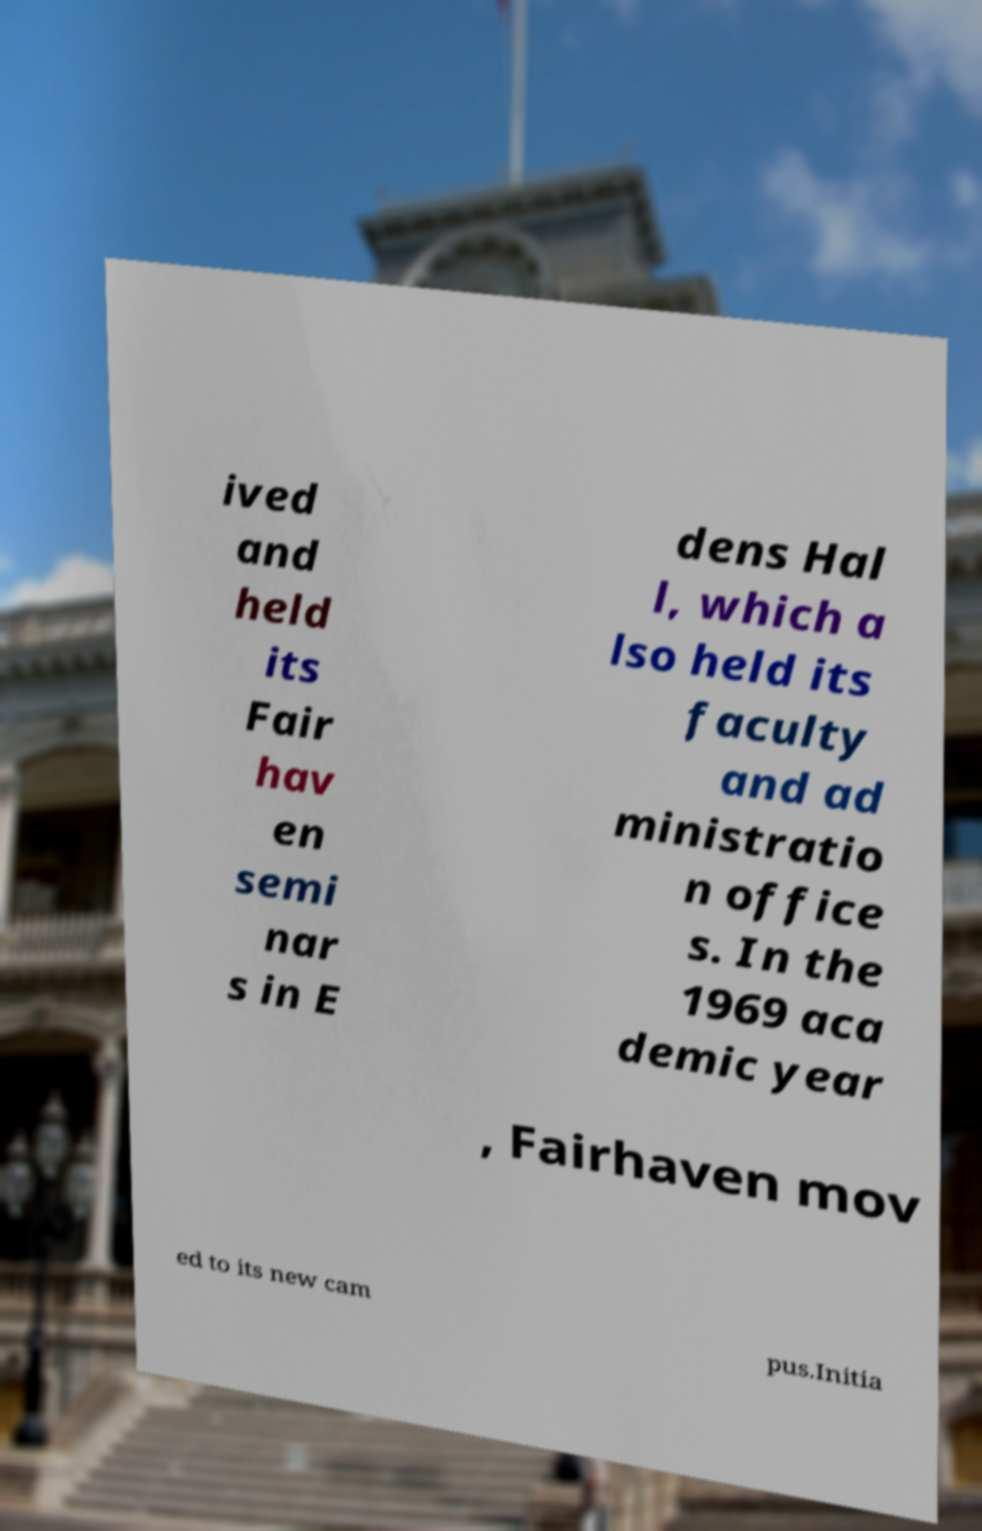Can you read and provide the text displayed in the image?This photo seems to have some interesting text. Can you extract and type it out for me? ived and held its Fair hav en semi nar s in E dens Hal l, which a lso held its faculty and ad ministratio n office s. In the 1969 aca demic year , Fairhaven mov ed to its new cam pus.Initia 